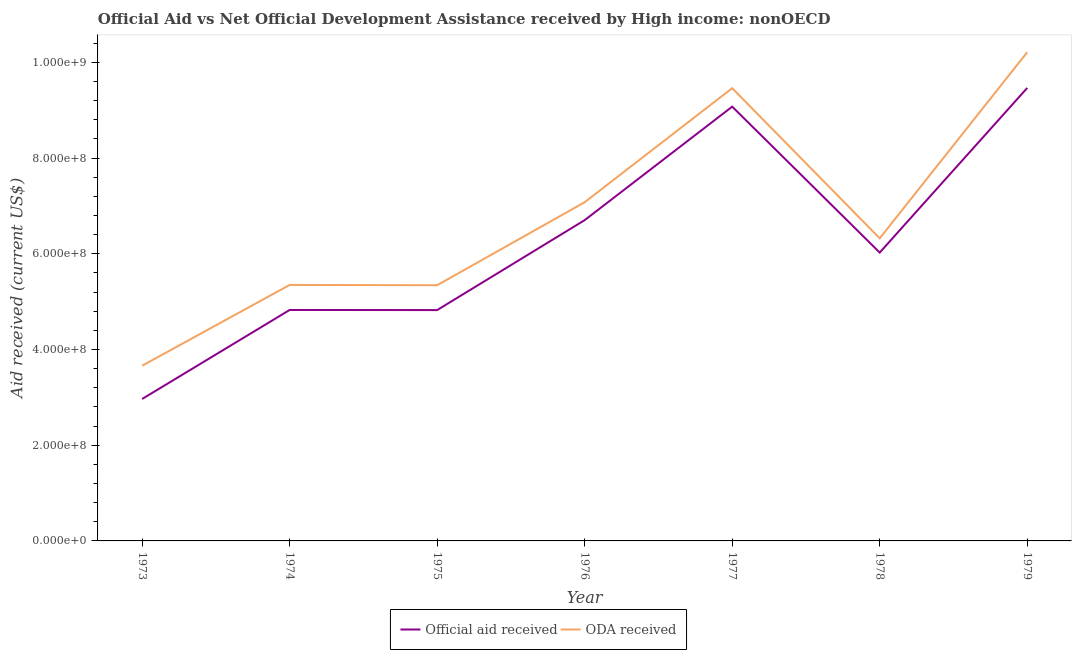Is the number of lines equal to the number of legend labels?
Your answer should be very brief. Yes. What is the oda received in 1975?
Offer a very short reply. 5.34e+08. Across all years, what is the maximum oda received?
Your response must be concise. 1.02e+09. Across all years, what is the minimum oda received?
Your answer should be compact. 3.66e+08. In which year was the oda received maximum?
Make the answer very short. 1979. In which year was the official aid received minimum?
Your answer should be very brief. 1973. What is the total official aid received in the graph?
Your answer should be compact. 4.39e+09. What is the difference between the official aid received in 1974 and that in 1975?
Keep it short and to the point. 2.50e+05. What is the difference between the official aid received in 1974 and the oda received in 1973?
Provide a succinct answer. 1.16e+08. What is the average oda received per year?
Your answer should be compact. 6.78e+08. In the year 1977, what is the difference between the official aid received and oda received?
Offer a very short reply. -3.86e+07. What is the ratio of the official aid received in 1976 to that in 1978?
Keep it short and to the point. 1.11. Is the official aid received in 1974 less than that in 1977?
Provide a succinct answer. Yes. What is the difference between the highest and the second highest official aid received?
Provide a short and direct response. 3.91e+07. What is the difference between the highest and the lowest official aid received?
Give a very brief answer. 6.50e+08. Does the official aid received monotonically increase over the years?
Keep it short and to the point. No. Is the official aid received strictly greater than the oda received over the years?
Provide a succinct answer. No. How many lines are there?
Provide a succinct answer. 2. How many years are there in the graph?
Provide a short and direct response. 7. What is the difference between two consecutive major ticks on the Y-axis?
Provide a succinct answer. 2.00e+08. Does the graph contain any zero values?
Your response must be concise. No. Does the graph contain grids?
Your answer should be compact. No. How many legend labels are there?
Provide a short and direct response. 2. What is the title of the graph?
Offer a very short reply. Official Aid vs Net Official Development Assistance received by High income: nonOECD . Does "Pregnant women" appear as one of the legend labels in the graph?
Ensure brevity in your answer.  No. What is the label or title of the Y-axis?
Offer a very short reply. Aid received (current US$). What is the Aid received (current US$) of Official aid received in 1973?
Your answer should be compact. 2.97e+08. What is the Aid received (current US$) of ODA received in 1973?
Provide a succinct answer. 3.66e+08. What is the Aid received (current US$) in Official aid received in 1974?
Your answer should be compact. 4.83e+08. What is the Aid received (current US$) of ODA received in 1974?
Your answer should be compact. 5.35e+08. What is the Aid received (current US$) in Official aid received in 1975?
Provide a succinct answer. 4.82e+08. What is the Aid received (current US$) in ODA received in 1975?
Offer a terse response. 5.34e+08. What is the Aid received (current US$) of Official aid received in 1976?
Your answer should be compact. 6.70e+08. What is the Aid received (current US$) in ODA received in 1976?
Provide a short and direct response. 7.08e+08. What is the Aid received (current US$) in Official aid received in 1977?
Offer a very short reply. 9.07e+08. What is the Aid received (current US$) of ODA received in 1977?
Offer a very short reply. 9.46e+08. What is the Aid received (current US$) of Official aid received in 1978?
Offer a very short reply. 6.03e+08. What is the Aid received (current US$) in ODA received in 1978?
Provide a succinct answer. 6.32e+08. What is the Aid received (current US$) in Official aid received in 1979?
Provide a short and direct response. 9.47e+08. What is the Aid received (current US$) in ODA received in 1979?
Give a very brief answer. 1.02e+09. Across all years, what is the maximum Aid received (current US$) of Official aid received?
Ensure brevity in your answer.  9.47e+08. Across all years, what is the maximum Aid received (current US$) of ODA received?
Provide a succinct answer. 1.02e+09. Across all years, what is the minimum Aid received (current US$) in Official aid received?
Your answer should be very brief. 2.97e+08. Across all years, what is the minimum Aid received (current US$) in ODA received?
Give a very brief answer. 3.66e+08. What is the total Aid received (current US$) in Official aid received in the graph?
Offer a very short reply. 4.39e+09. What is the total Aid received (current US$) of ODA received in the graph?
Provide a short and direct response. 4.74e+09. What is the difference between the Aid received (current US$) in Official aid received in 1973 and that in 1974?
Provide a succinct answer. -1.86e+08. What is the difference between the Aid received (current US$) of ODA received in 1973 and that in 1974?
Provide a short and direct response. -1.69e+08. What is the difference between the Aid received (current US$) of Official aid received in 1973 and that in 1975?
Your response must be concise. -1.86e+08. What is the difference between the Aid received (current US$) of ODA received in 1973 and that in 1975?
Your response must be concise. -1.68e+08. What is the difference between the Aid received (current US$) of Official aid received in 1973 and that in 1976?
Your response must be concise. -3.74e+08. What is the difference between the Aid received (current US$) of ODA received in 1973 and that in 1976?
Your answer should be compact. -3.42e+08. What is the difference between the Aid received (current US$) in Official aid received in 1973 and that in 1977?
Your answer should be very brief. -6.11e+08. What is the difference between the Aid received (current US$) in ODA received in 1973 and that in 1977?
Provide a succinct answer. -5.80e+08. What is the difference between the Aid received (current US$) of Official aid received in 1973 and that in 1978?
Ensure brevity in your answer.  -3.06e+08. What is the difference between the Aid received (current US$) of ODA received in 1973 and that in 1978?
Your answer should be very brief. -2.66e+08. What is the difference between the Aid received (current US$) in Official aid received in 1973 and that in 1979?
Make the answer very short. -6.50e+08. What is the difference between the Aid received (current US$) of ODA received in 1973 and that in 1979?
Ensure brevity in your answer.  -6.55e+08. What is the difference between the Aid received (current US$) of ODA received in 1974 and that in 1975?
Make the answer very short. 5.80e+05. What is the difference between the Aid received (current US$) in Official aid received in 1974 and that in 1976?
Provide a succinct answer. -1.88e+08. What is the difference between the Aid received (current US$) of ODA received in 1974 and that in 1976?
Offer a terse response. -1.73e+08. What is the difference between the Aid received (current US$) in Official aid received in 1974 and that in 1977?
Offer a very short reply. -4.25e+08. What is the difference between the Aid received (current US$) of ODA received in 1974 and that in 1977?
Keep it short and to the point. -4.11e+08. What is the difference between the Aid received (current US$) of Official aid received in 1974 and that in 1978?
Offer a very short reply. -1.20e+08. What is the difference between the Aid received (current US$) of ODA received in 1974 and that in 1978?
Your answer should be compact. -9.74e+07. What is the difference between the Aid received (current US$) in Official aid received in 1974 and that in 1979?
Provide a succinct answer. -4.64e+08. What is the difference between the Aid received (current US$) of ODA received in 1974 and that in 1979?
Give a very brief answer. -4.86e+08. What is the difference between the Aid received (current US$) of Official aid received in 1975 and that in 1976?
Keep it short and to the point. -1.88e+08. What is the difference between the Aid received (current US$) in ODA received in 1975 and that in 1976?
Make the answer very short. -1.73e+08. What is the difference between the Aid received (current US$) of Official aid received in 1975 and that in 1977?
Give a very brief answer. -4.25e+08. What is the difference between the Aid received (current US$) of ODA received in 1975 and that in 1977?
Offer a very short reply. -4.12e+08. What is the difference between the Aid received (current US$) in Official aid received in 1975 and that in 1978?
Keep it short and to the point. -1.20e+08. What is the difference between the Aid received (current US$) in ODA received in 1975 and that in 1978?
Keep it short and to the point. -9.80e+07. What is the difference between the Aid received (current US$) in Official aid received in 1975 and that in 1979?
Offer a very short reply. -4.64e+08. What is the difference between the Aid received (current US$) in ODA received in 1975 and that in 1979?
Provide a succinct answer. -4.87e+08. What is the difference between the Aid received (current US$) of Official aid received in 1976 and that in 1977?
Make the answer very short. -2.37e+08. What is the difference between the Aid received (current US$) of ODA received in 1976 and that in 1977?
Offer a very short reply. -2.38e+08. What is the difference between the Aid received (current US$) in Official aid received in 1976 and that in 1978?
Ensure brevity in your answer.  6.78e+07. What is the difference between the Aid received (current US$) in ODA received in 1976 and that in 1978?
Your answer should be very brief. 7.55e+07. What is the difference between the Aid received (current US$) of Official aid received in 1976 and that in 1979?
Give a very brief answer. -2.76e+08. What is the difference between the Aid received (current US$) of ODA received in 1976 and that in 1979?
Your answer should be compact. -3.13e+08. What is the difference between the Aid received (current US$) of Official aid received in 1977 and that in 1978?
Your answer should be very brief. 3.05e+08. What is the difference between the Aid received (current US$) of ODA received in 1977 and that in 1978?
Your answer should be compact. 3.14e+08. What is the difference between the Aid received (current US$) in Official aid received in 1977 and that in 1979?
Your answer should be compact. -3.91e+07. What is the difference between the Aid received (current US$) of ODA received in 1977 and that in 1979?
Give a very brief answer. -7.52e+07. What is the difference between the Aid received (current US$) in Official aid received in 1978 and that in 1979?
Make the answer very short. -3.44e+08. What is the difference between the Aid received (current US$) of ODA received in 1978 and that in 1979?
Your answer should be compact. -3.89e+08. What is the difference between the Aid received (current US$) of Official aid received in 1973 and the Aid received (current US$) of ODA received in 1974?
Offer a terse response. -2.38e+08. What is the difference between the Aid received (current US$) of Official aid received in 1973 and the Aid received (current US$) of ODA received in 1975?
Make the answer very short. -2.38e+08. What is the difference between the Aid received (current US$) of Official aid received in 1973 and the Aid received (current US$) of ODA received in 1976?
Provide a short and direct response. -4.11e+08. What is the difference between the Aid received (current US$) of Official aid received in 1973 and the Aid received (current US$) of ODA received in 1977?
Your answer should be compact. -6.49e+08. What is the difference between the Aid received (current US$) of Official aid received in 1973 and the Aid received (current US$) of ODA received in 1978?
Offer a terse response. -3.36e+08. What is the difference between the Aid received (current US$) of Official aid received in 1973 and the Aid received (current US$) of ODA received in 1979?
Ensure brevity in your answer.  -7.25e+08. What is the difference between the Aid received (current US$) in Official aid received in 1974 and the Aid received (current US$) in ODA received in 1975?
Your response must be concise. -5.17e+07. What is the difference between the Aid received (current US$) in Official aid received in 1974 and the Aid received (current US$) in ODA received in 1976?
Offer a very short reply. -2.25e+08. What is the difference between the Aid received (current US$) in Official aid received in 1974 and the Aid received (current US$) in ODA received in 1977?
Keep it short and to the point. -4.63e+08. What is the difference between the Aid received (current US$) in Official aid received in 1974 and the Aid received (current US$) in ODA received in 1978?
Your answer should be very brief. -1.50e+08. What is the difference between the Aid received (current US$) in Official aid received in 1974 and the Aid received (current US$) in ODA received in 1979?
Give a very brief answer. -5.39e+08. What is the difference between the Aid received (current US$) in Official aid received in 1975 and the Aid received (current US$) in ODA received in 1976?
Your response must be concise. -2.25e+08. What is the difference between the Aid received (current US$) in Official aid received in 1975 and the Aid received (current US$) in ODA received in 1977?
Your answer should be very brief. -4.64e+08. What is the difference between the Aid received (current US$) of Official aid received in 1975 and the Aid received (current US$) of ODA received in 1978?
Provide a short and direct response. -1.50e+08. What is the difference between the Aid received (current US$) in Official aid received in 1975 and the Aid received (current US$) in ODA received in 1979?
Your answer should be compact. -5.39e+08. What is the difference between the Aid received (current US$) in Official aid received in 1976 and the Aid received (current US$) in ODA received in 1977?
Provide a short and direct response. -2.76e+08. What is the difference between the Aid received (current US$) of Official aid received in 1976 and the Aid received (current US$) of ODA received in 1978?
Offer a very short reply. 3.80e+07. What is the difference between the Aid received (current US$) in Official aid received in 1976 and the Aid received (current US$) in ODA received in 1979?
Give a very brief answer. -3.51e+08. What is the difference between the Aid received (current US$) in Official aid received in 1977 and the Aid received (current US$) in ODA received in 1978?
Your answer should be very brief. 2.75e+08. What is the difference between the Aid received (current US$) in Official aid received in 1977 and the Aid received (current US$) in ODA received in 1979?
Ensure brevity in your answer.  -1.14e+08. What is the difference between the Aid received (current US$) in Official aid received in 1978 and the Aid received (current US$) in ODA received in 1979?
Provide a short and direct response. -4.19e+08. What is the average Aid received (current US$) in Official aid received per year?
Your response must be concise. 6.27e+08. What is the average Aid received (current US$) of ODA received per year?
Ensure brevity in your answer.  6.78e+08. In the year 1973, what is the difference between the Aid received (current US$) of Official aid received and Aid received (current US$) of ODA received?
Ensure brevity in your answer.  -6.95e+07. In the year 1974, what is the difference between the Aid received (current US$) in Official aid received and Aid received (current US$) in ODA received?
Keep it short and to the point. -5.23e+07. In the year 1975, what is the difference between the Aid received (current US$) of Official aid received and Aid received (current US$) of ODA received?
Keep it short and to the point. -5.20e+07. In the year 1976, what is the difference between the Aid received (current US$) in Official aid received and Aid received (current US$) in ODA received?
Provide a succinct answer. -3.75e+07. In the year 1977, what is the difference between the Aid received (current US$) of Official aid received and Aid received (current US$) of ODA received?
Offer a terse response. -3.86e+07. In the year 1978, what is the difference between the Aid received (current US$) of Official aid received and Aid received (current US$) of ODA received?
Offer a very short reply. -2.98e+07. In the year 1979, what is the difference between the Aid received (current US$) of Official aid received and Aid received (current US$) of ODA received?
Give a very brief answer. -7.46e+07. What is the ratio of the Aid received (current US$) of Official aid received in 1973 to that in 1974?
Your answer should be compact. 0.61. What is the ratio of the Aid received (current US$) of ODA received in 1973 to that in 1974?
Your answer should be very brief. 0.68. What is the ratio of the Aid received (current US$) of Official aid received in 1973 to that in 1975?
Your answer should be compact. 0.61. What is the ratio of the Aid received (current US$) in ODA received in 1973 to that in 1975?
Keep it short and to the point. 0.69. What is the ratio of the Aid received (current US$) in Official aid received in 1973 to that in 1976?
Give a very brief answer. 0.44. What is the ratio of the Aid received (current US$) in ODA received in 1973 to that in 1976?
Your response must be concise. 0.52. What is the ratio of the Aid received (current US$) in Official aid received in 1973 to that in 1977?
Provide a short and direct response. 0.33. What is the ratio of the Aid received (current US$) of ODA received in 1973 to that in 1977?
Offer a terse response. 0.39. What is the ratio of the Aid received (current US$) in Official aid received in 1973 to that in 1978?
Offer a terse response. 0.49. What is the ratio of the Aid received (current US$) of ODA received in 1973 to that in 1978?
Your answer should be compact. 0.58. What is the ratio of the Aid received (current US$) in Official aid received in 1973 to that in 1979?
Make the answer very short. 0.31. What is the ratio of the Aid received (current US$) in ODA received in 1973 to that in 1979?
Your answer should be compact. 0.36. What is the ratio of the Aid received (current US$) of Official aid received in 1974 to that in 1976?
Offer a terse response. 0.72. What is the ratio of the Aid received (current US$) in ODA received in 1974 to that in 1976?
Give a very brief answer. 0.76. What is the ratio of the Aid received (current US$) of Official aid received in 1974 to that in 1977?
Offer a very short reply. 0.53. What is the ratio of the Aid received (current US$) of ODA received in 1974 to that in 1977?
Ensure brevity in your answer.  0.57. What is the ratio of the Aid received (current US$) in Official aid received in 1974 to that in 1978?
Provide a short and direct response. 0.8. What is the ratio of the Aid received (current US$) of ODA received in 1974 to that in 1978?
Offer a very short reply. 0.85. What is the ratio of the Aid received (current US$) of Official aid received in 1974 to that in 1979?
Provide a short and direct response. 0.51. What is the ratio of the Aid received (current US$) in ODA received in 1974 to that in 1979?
Provide a succinct answer. 0.52. What is the ratio of the Aid received (current US$) in Official aid received in 1975 to that in 1976?
Offer a terse response. 0.72. What is the ratio of the Aid received (current US$) of ODA received in 1975 to that in 1976?
Your answer should be compact. 0.75. What is the ratio of the Aid received (current US$) of Official aid received in 1975 to that in 1977?
Make the answer very short. 0.53. What is the ratio of the Aid received (current US$) in ODA received in 1975 to that in 1977?
Give a very brief answer. 0.56. What is the ratio of the Aid received (current US$) in Official aid received in 1975 to that in 1978?
Provide a short and direct response. 0.8. What is the ratio of the Aid received (current US$) in ODA received in 1975 to that in 1978?
Give a very brief answer. 0.84. What is the ratio of the Aid received (current US$) of Official aid received in 1975 to that in 1979?
Make the answer very short. 0.51. What is the ratio of the Aid received (current US$) in ODA received in 1975 to that in 1979?
Provide a succinct answer. 0.52. What is the ratio of the Aid received (current US$) in Official aid received in 1976 to that in 1977?
Make the answer very short. 0.74. What is the ratio of the Aid received (current US$) of ODA received in 1976 to that in 1977?
Your response must be concise. 0.75. What is the ratio of the Aid received (current US$) of Official aid received in 1976 to that in 1978?
Offer a terse response. 1.11. What is the ratio of the Aid received (current US$) of ODA received in 1976 to that in 1978?
Give a very brief answer. 1.12. What is the ratio of the Aid received (current US$) of Official aid received in 1976 to that in 1979?
Offer a very short reply. 0.71. What is the ratio of the Aid received (current US$) of ODA received in 1976 to that in 1979?
Keep it short and to the point. 0.69. What is the ratio of the Aid received (current US$) in Official aid received in 1977 to that in 1978?
Make the answer very short. 1.51. What is the ratio of the Aid received (current US$) in ODA received in 1977 to that in 1978?
Offer a very short reply. 1.5. What is the ratio of the Aid received (current US$) in Official aid received in 1977 to that in 1979?
Your response must be concise. 0.96. What is the ratio of the Aid received (current US$) of ODA received in 1977 to that in 1979?
Offer a very short reply. 0.93. What is the ratio of the Aid received (current US$) in Official aid received in 1978 to that in 1979?
Provide a succinct answer. 0.64. What is the ratio of the Aid received (current US$) in ODA received in 1978 to that in 1979?
Your answer should be very brief. 0.62. What is the difference between the highest and the second highest Aid received (current US$) in Official aid received?
Offer a very short reply. 3.91e+07. What is the difference between the highest and the second highest Aid received (current US$) of ODA received?
Your answer should be very brief. 7.52e+07. What is the difference between the highest and the lowest Aid received (current US$) in Official aid received?
Make the answer very short. 6.50e+08. What is the difference between the highest and the lowest Aid received (current US$) of ODA received?
Keep it short and to the point. 6.55e+08. 